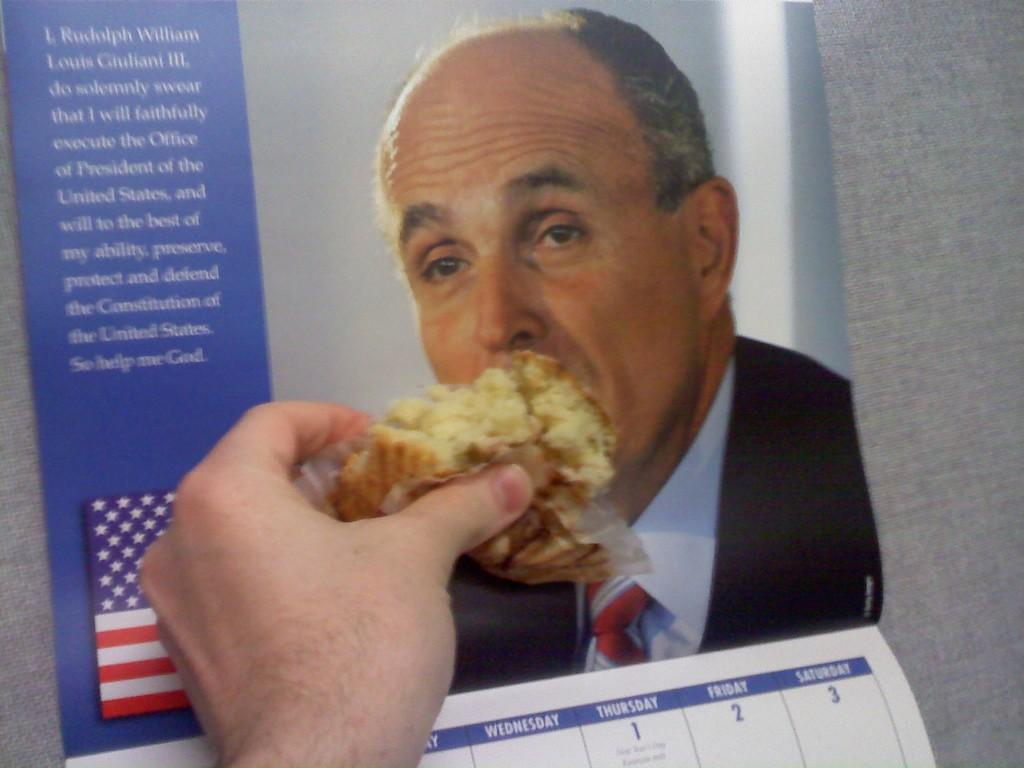Provide a one-sentence caption for the provided image. A calendar with a picture of Rudy Giuliani on it. 